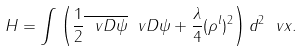Convert formula to latex. <formula><loc_0><loc_0><loc_500><loc_500>H = \int \left ( \frac { 1 } { 2 } \overline { \ v D \psi } \ v D \psi + \frac { \lambda } { 4 } ( \rho ^ { l } ) ^ { 2 } \right ) d ^ { 2 } \ v x .</formula> 